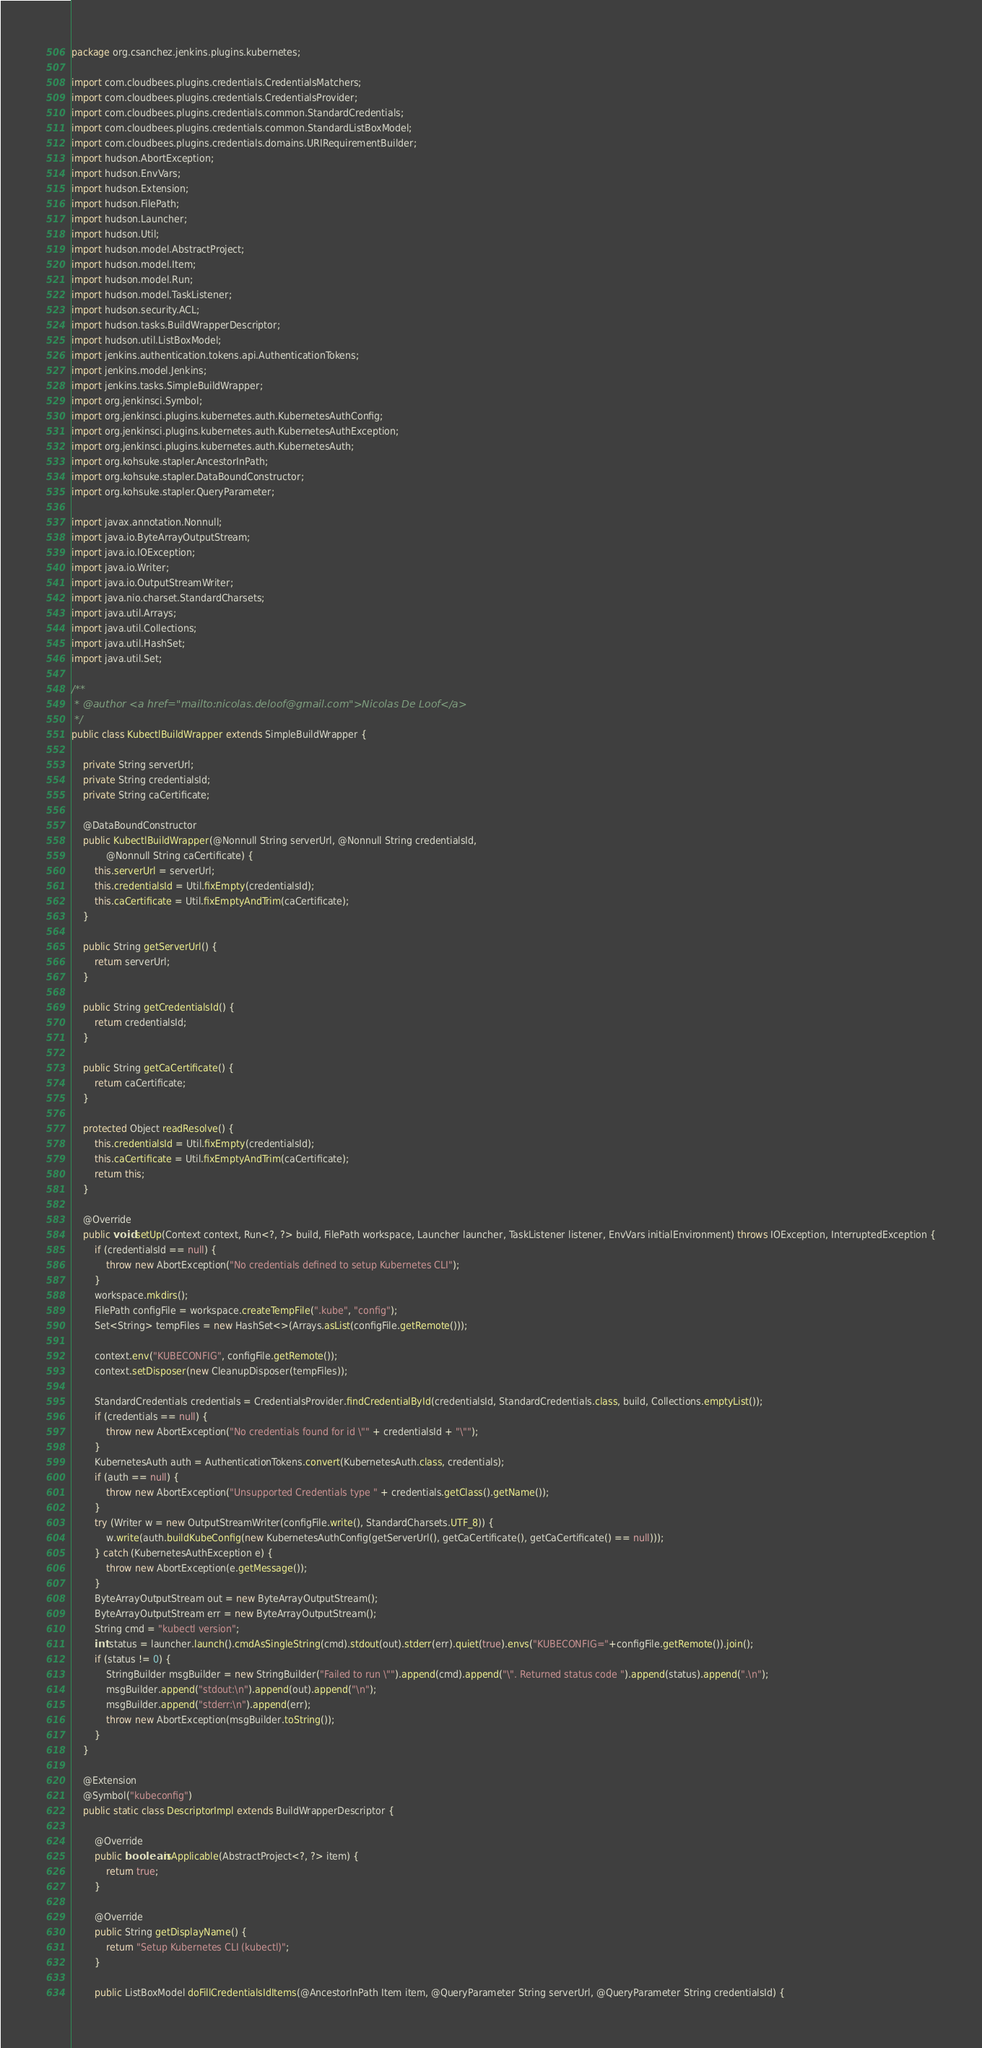Convert code to text. <code><loc_0><loc_0><loc_500><loc_500><_Java_>package org.csanchez.jenkins.plugins.kubernetes;

import com.cloudbees.plugins.credentials.CredentialsMatchers;
import com.cloudbees.plugins.credentials.CredentialsProvider;
import com.cloudbees.plugins.credentials.common.StandardCredentials;
import com.cloudbees.plugins.credentials.common.StandardListBoxModel;
import com.cloudbees.plugins.credentials.domains.URIRequirementBuilder;
import hudson.AbortException;
import hudson.EnvVars;
import hudson.Extension;
import hudson.FilePath;
import hudson.Launcher;
import hudson.Util;
import hudson.model.AbstractProject;
import hudson.model.Item;
import hudson.model.Run;
import hudson.model.TaskListener;
import hudson.security.ACL;
import hudson.tasks.BuildWrapperDescriptor;
import hudson.util.ListBoxModel;
import jenkins.authentication.tokens.api.AuthenticationTokens;
import jenkins.model.Jenkins;
import jenkins.tasks.SimpleBuildWrapper;
import org.jenkinsci.Symbol;
import org.jenkinsci.plugins.kubernetes.auth.KubernetesAuthConfig;
import org.jenkinsci.plugins.kubernetes.auth.KubernetesAuthException;
import org.jenkinsci.plugins.kubernetes.auth.KubernetesAuth;
import org.kohsuke.stapler.AncestorInPath;
import org.kohsuke.stapler.DataBoundConstructor;
import org.kohsuke.stapler.QueryParameter;

import javax.annotation.Nonnull;
import java.io.ByteArrayOutputStream;
import java.io.IOException;
import java.io.Writer;
import java.io.OutputStreamWriter;
import java.nio.charset.StandardCharsets;
import java.util.Arrays;
import java.util.Collections;
import java.util.HashSet;
import java.util.Set;

/**
 * @author <a href="mailto:nicolas.deloof@gmail.com">Nicolas De Loof</a>
 */
public class KubectlBuildWrapper extends SimpleBuildWrapper {

    private String serverUrl;
    private String credentialsId;
    private String caCertificate;

    @DataBoundConstructor
    public KubectlBuildWrapper(@Nonnull String serverUrl, @Nonnull String credentialsId,
            @Nonnull String caCertificate) {
        this.serverUrl = serverUrl;
        this.credentialsId = Util.fixEmpty(credentialsId);
        this.caCertificate = Util.fixEmptyAndTrim(caCertificate);
    }

    public String getServerUrl() {
        return serverUrl;
    }

    public String getCredentialsId() {
        return credentialsId;
    }

    public String getCaCertificate() {
        return caCertificate;
    }

    protected Object readResolve() {
        this.credentialsId = Util.fixEmpty(credentialsId);
        this.caCertificate = Util.fixEmptyAndTrim(caCertificate);
        return this;
    }

    @Override
    public void setUp(Context context, Run<?, ?> build, FilePath workspace, Launcher launcher, TaskListener listener, EnvVars initialEnvironment) throws IOException, InterruptedException {
        if (credentialsId == null) {
            throw new AbortException("No credentials defined to setup Kubernetes CLI");
        }
        workspace.mkdirs();
        FilePath configFile = workspace.createTempFile(".kube", "config");
        Set<String> tempFiles = new HashSet<>(Arrays.asList(configFile.getRemote()));

        context.env("KUBECONFIG", configFile.getRemote());
        context.setDisposer(new CleanupDisposer(tempFiles));

        StandardCredentials credentials = CredentialsProvider.findCredentialById(credentialsId, StandardCredentials.class, build, Collections.emptyList());
        if (credentials == null) {
            throw new AbortException("No credentials found for id \"" + credentialsId + "\"");
        }
        KubernetesAuth auth = AuthenticationTokens.convert(KubernetesAuth.class, credentials);
        if (auth == null) {
            throw new AbortException("Unsupported Credentials type " + credentials.getClass().getName());
        }
        try (Writer w = new OutputStreamWriter(configFile.write(), StandardCharsets.UTF_8)) {
            w.write(auth.buildKubeConfig(new KubernetesAuthConfig(getServerUrl(), getCaCertificate(), getCaCertificate() == null)));
        } catch (KubernetesAuthException e) {
            throw new AbortException(e.getMessage());
        }
        ByteArrayOutputStream out = new ByteArrayOutputStream();
        ByteArrayOutputStream err = new ByteArrayOutputStream();
        String cmd = "kubectl version";
        int status = launcher.launch().cmdAsSingleString(cmd).stdout(out).stderr(err).quiet(true).envs("KUBECONFIG="+configFile.getRemote()).join();
        if (status != 0) {
            StringBuilder msgBuilder = new StringBuilder("Failed to run \"").append(cmd).append("\". Returned status code ").append(status).append(".\n");
            msgBuilder.append("stdout:\n").append(out).append("\n");
            msgBuilder.append("stderr:\n").append(err);
            throw new AbortException(msgBuilder.toString());
        }
    }

    @Extension
    @Symbol("kubeconfig")
    public static class DescriptorImpl extends BuildWrapperDescriptor {

        @Override
        public boolean isApplicable(AbstractProject<?, ?> item) {
            return true;
        }

        @Override
        public String getDisplayName() {
            return "Setup Kubernetes CLI (kubectl)";
        }

        public ListBoxModel doFillCredentialsIdItems(@AncestorInPath Item item, @QueryParameter String serverUrl, @QueryParameter String credentialsId) {</code> 